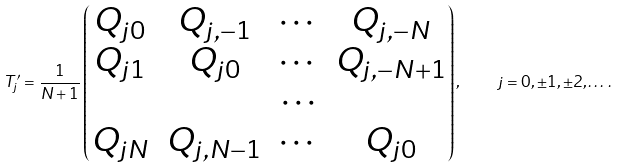Convert formula to latex. <formula><loc_0><loc_0><loc_500><loc_500>T _ { j } ^ { \prime } = \frac { 1 } { N + 1 } \begin{pmatrix} Q _ { j 0 } & Q _ { j , - 1 } & \cdots & Q _ { j , - N } \\ Q _ { j 1 } & Q _ { j 0 } & \cdots & Q _ { j , - N + 1 } \\ & & \cdots \\ Q _ { j N } & Q _ { j , N - 1 } & \cdots & Q _ { j 0 } \\ \end{pmatrix} , \quad j = 0 , \pm 1 , \pm 2 , \dots \, .</formula> 